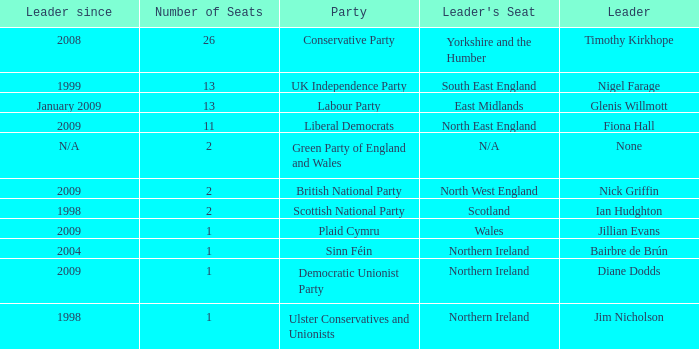What is Jillian Evans highest number of seats? 1.0. Could you parse the entire table as a dict? {'header': ['Leader since', 'Number of Seats', 'Party', "Leader's Seat", 'Leader'], 'rows': [['2008', '26', 'Conservative Party', 'Yorkshire and the Humber', 'Timothy Kirkhope'], ['1999', '13', 'UK Independence Party', 'South East England', 'Nigel Farage'], ['January 2009', '13', 'Labour Party', 'East Midlands', 'Glenis Willmott'], ['2009', '11', 'Liberal Democrats', 'North East England', 'Fiona Hall'], ['N/A', '2', 'Green Party of England and Wales', 'N/A', 'None'], ['2009', '2', 'British National Party', 'North West England', 'Nick Griffin'], ['1998', '2', 'Scottish National Party', 'Scotland', 'Ian Hudghton'], ['2009', '1', 'Plaid Cymru', 'Wales', 'Jillian Evans'], ['2004', '1', 'Sinn Féin', 'Northern Ireland', 'Bairbre de Brún'], ['2009', '1', 'Democratic Unionist Party', 'Northern Ireland', 'Diane Dodds'], ['1998', '1', 'Ulster Conservatives and Unionists', 'Northern Ireland', 'Jim Nicholson']]} 